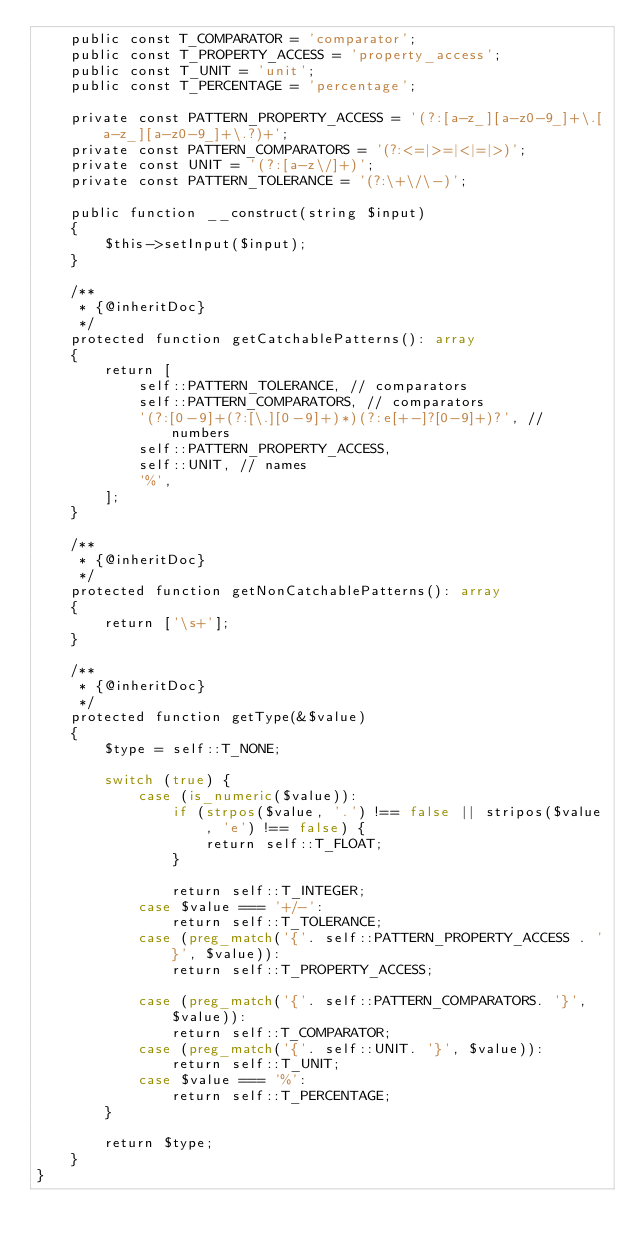<code> <loc_0><loc_0><loc_500><loc_500><_PHP_>    public const T_COMPARATOR = 'comparator';
    public const T_PROPERTY_ACCESS = 'property_access';
    public const T_UNIT = 'unit';
    public const T_PERCENTAGE = 'percentage';

    private const PATTERN_PROPERTY_ACCESS = '(?:[a-z_][a-z0-9_]+\.[a-z_][a-z0-9_]+\.?)+';
    private const PATTERN_COMPARATORS = '(?:<=|>=|<|=|>)';
    private const UNIT = '(?:[a-z\/]+)';
    private const PATTERN_TOLERANCE = '(?:\+\/\-)';

    public function __construct(string $input)
    {
        $this->setInput($input);
    }

    /**
     * {@inheritDoc}
     */
    protected function getCatchablePatterns(): array
    {
        return [
            self::PATTERN_TOLERANCE, // comparators
            self::PATTERN_COMPARATORS, // comparators
            '(?:[0-9]+(?:[\.][0-9]+)*)(?:e[+-]?[0-9]+)?', // numbers
            self::PATTERN_PROPERTY_ACCESS,
            self::UNIT, // names
            '%',
        ];
    }

    /**
     * {@inheritDoc}
     */
    protected function getNonCatchablePatterns(): array
    {
        return ['\s+'];
    }

    /**
     * {@inheritDoc}
     */
    protected function getType(&$value)
    {
        $type = self::T_NONE;

        switch (true) {
            case (is_numeric($value)):
                if (strpos($value, '.') !== false || stripos($value, 'e') !== false) {
                    return self::T_FLOAT;
                }

                return self::T_INTEGER;
            case $value === '+/-':
                return self::T_TOLERANCE;
            case (preg_match('{'. self::PATTERN_PROPERTY_ACCESS . '}', $value)):
                return self::T_PROPERTY_ACCESS;

            case (preg_match('{'. self::PATTERN_COMPARATORS. '}', $value)):
                return self::T_COMPARATOR;
            case (preg_match('{'. self::UNIT. '}', $value)):
                return self::T_UNIT;
            case $value === '%':
                return self::T_PERCENTAGE;
        }

        return $type;
    }
}
</code> 